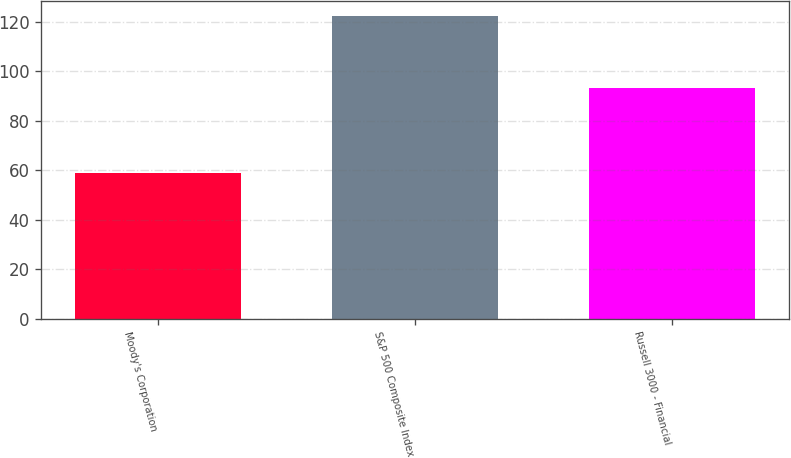Convert chart to OTSL. <chart><loc_0><loc_0><loc_500><loc_500><bar_chart><fcel>Moody's Corporation<fcel>S&P 500 Composite Index<fcel>Russell 3000 - Financial<nl><fcel>58.74<fcel>122.16<fcel>93.33<nl></chart> 